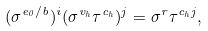<formula> <loc_0><loc_0><loc_500><loc_500>( \sigma ^ { e _ { 0 } / b } ) ^ { i } ( \sigma ^ { v _ { h } } \tau ^ { c _ { h } } ) ^ { j } = \sigma ^ { r } \tau ^ { c _ { h } j } ,</formula> 